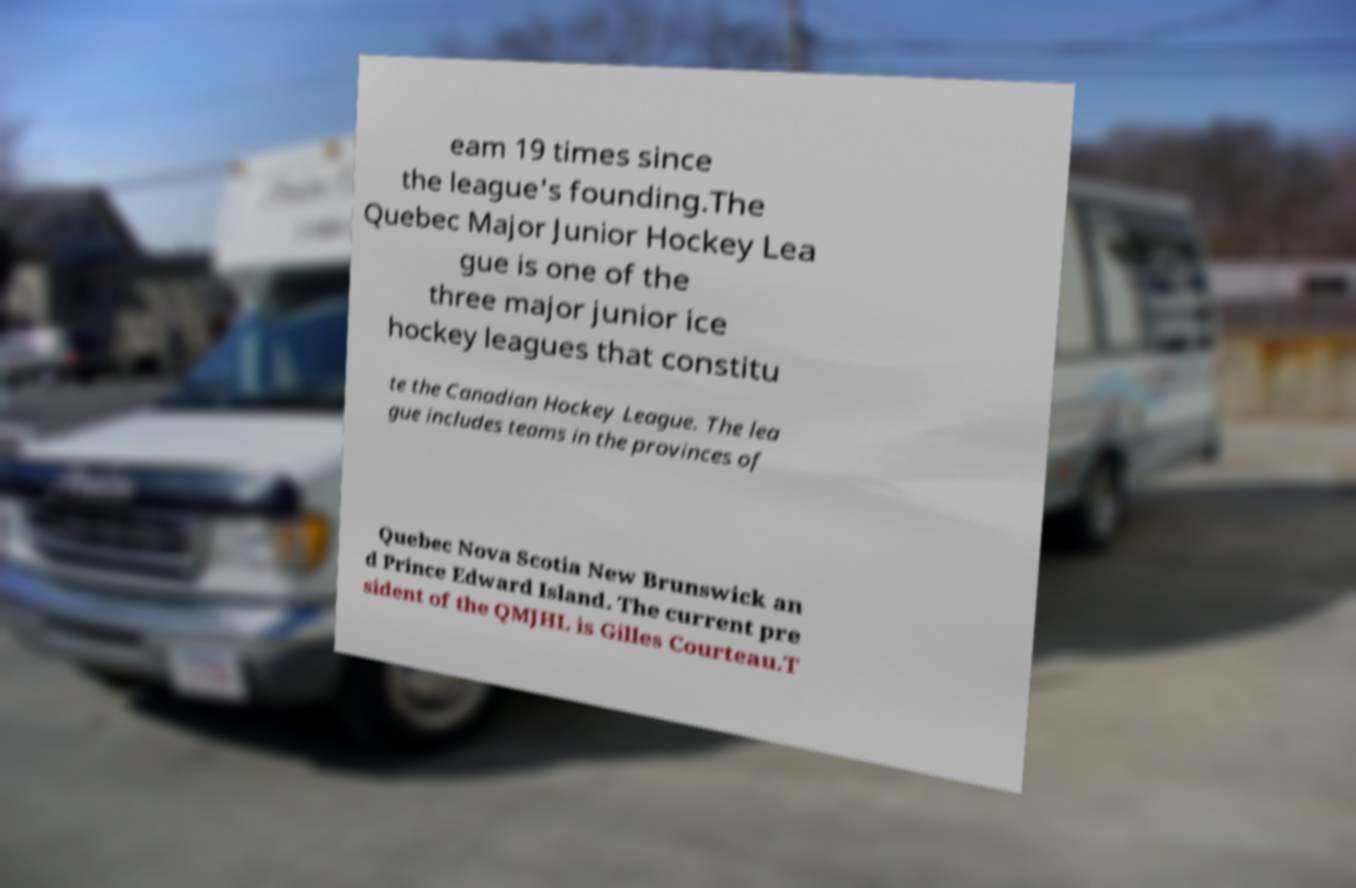For documentation purposes, I need the text within this image transcribed. Could you provide that? eam 19 times since the league's founding.The Quebec Major Junior Hockey Lea gue is one of the three major junior ice hockey leagues that constitu te the Canadian Hockey League. The lea gue includes teams in the provinces of Quebec Nova Scotia New Brunswick an d Prince Edward Island. The current pre sident of the QMJHL is Gilles Courteau.T 